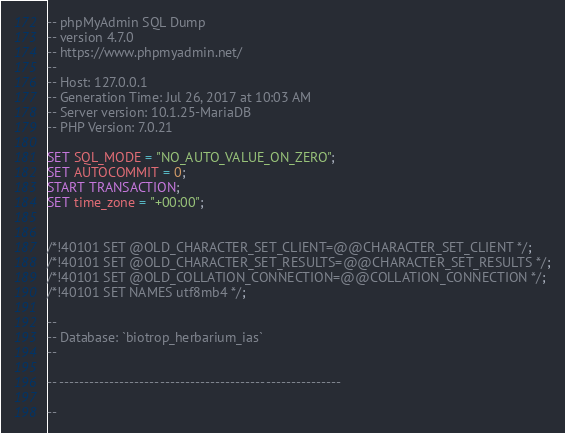Convert code to text. <code><loc_0><loc_0><loc_500><loc_500><_SQL_>-- phpMyAdmin SQL Dump
-- version 4.7.0
-- https://www.phpmyadmin.net/
--
-- Host: 127.0.0.1
-- Generation Time: Jul 26, 2017 at 10:03 AM
-- Server version: 10.1.25-MariaDB
-- PHP Version: 7.0.21

SET SQL_MODE = "NO_AUTO_VALUE_ON_ZERO";
SET AUTOCOMMIT = 0;
START TRANSACTION;
SET time_zone = "+00:00";


/*!40101 SET @OLD_CHARACTER_SET_CLIENT=@@CHARACTER_SET_CLIENT */;
/*!40101 SET @OLD_CHARACTER_SET_RESULTS=@@CHARACTER_SET_RESULTS */;
/*!40101 SET @OLD_COLLATION_CONNECTION=@@COLLATION_CONNECTION */;
/*!40101 SET NAMES utf8mb4 */;

--
-- Database: `biotrop_herbarium_ias`
--

-- --------------------------------------------------------

--</code> 